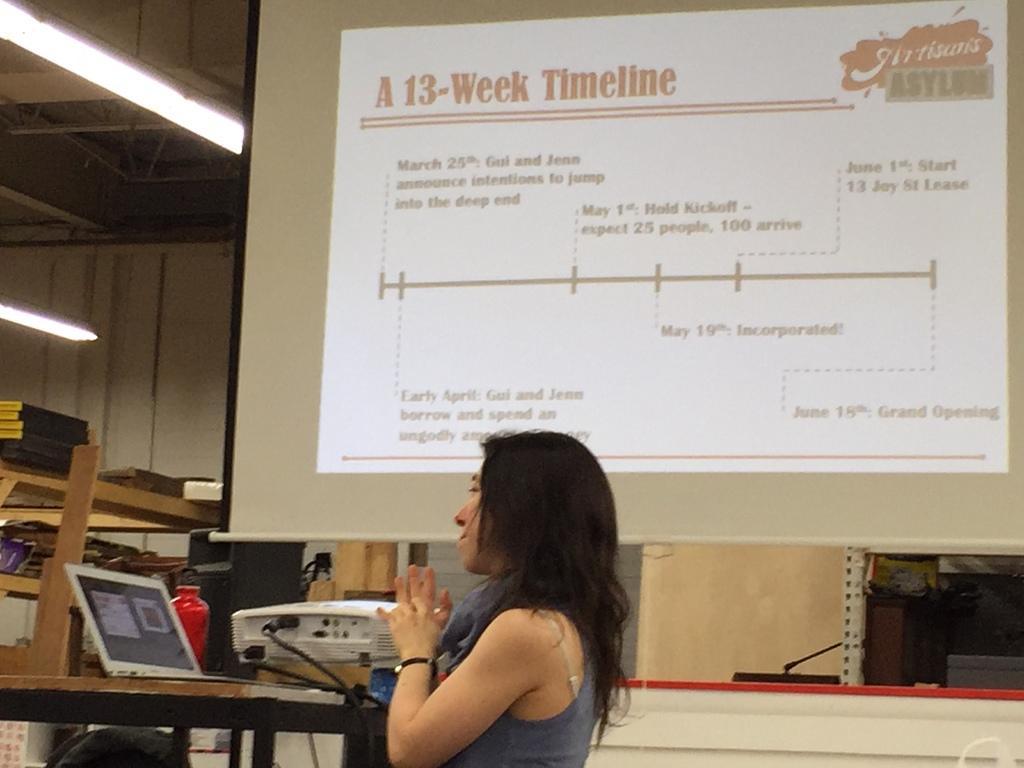Could you give a brief overview of what you see in this image? In this image we can see a woman standing. There are laptop, projector, lights and projector screen in the background. 